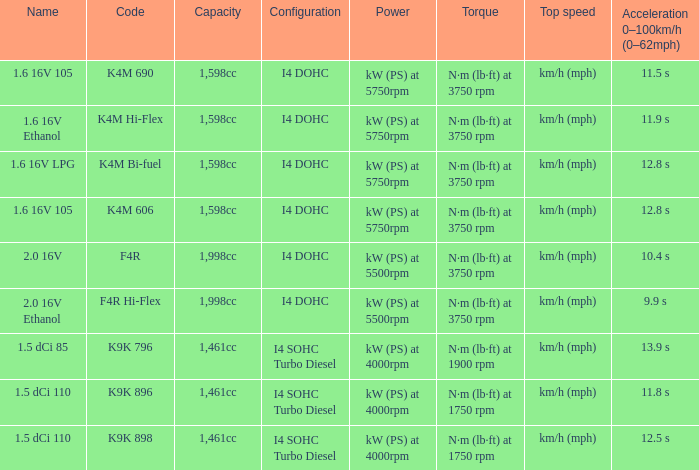What is the storage limit of code f4r? 1,998cc. 